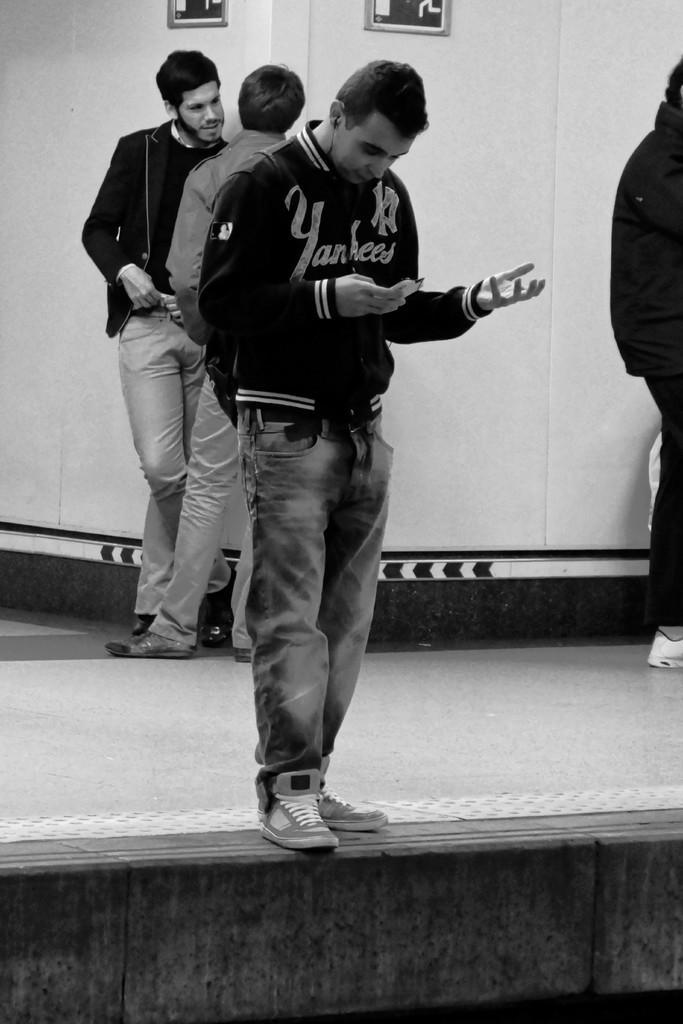Could you give a brief overview of what you see in this image? In this image I can see the black and white picture in which I can see a person wearing black color dress is standing and holding an object in his hand. In the background I can see few other persons standing, the wall and two boards attached to the wall. 